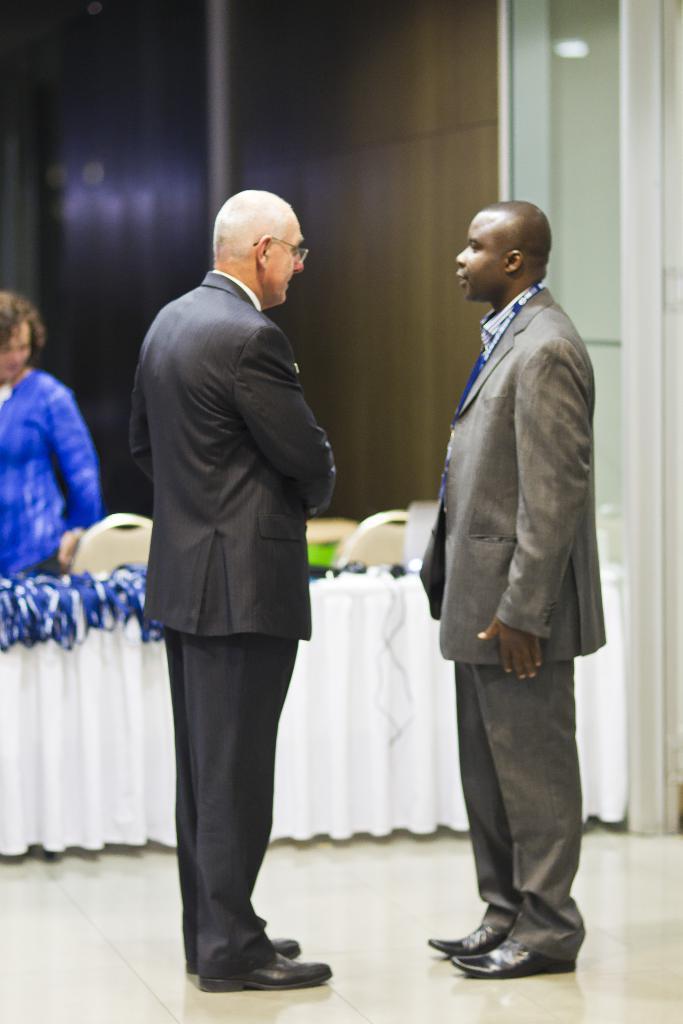How many people are in the image? There are two people standing in the center of the image. What are the two people wearing? The two people are wearing suits. Can you describe the lady in the background of the image? There is a lady in the background of the image, but no specific details are provided. What is on the table in the image? There is a table with a white cloth in the image. What furniture is present in the image? There are chairs in the image. How many dinosaurs can be seen in the image? There are no dinosaurs present in the image. 